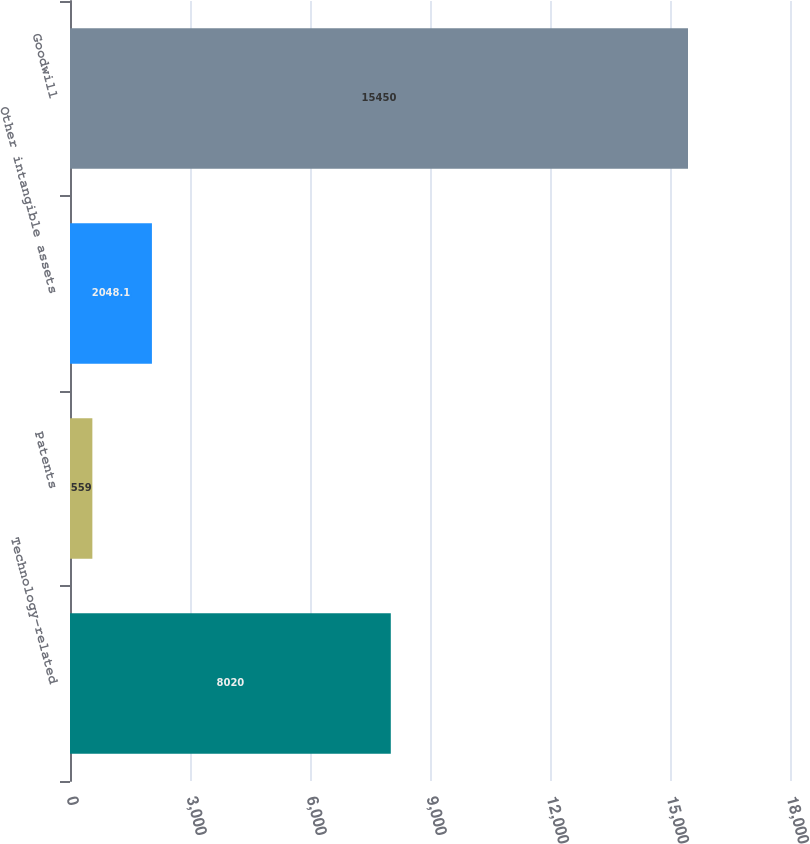<chart> <loc_0><loc_0><loc_500><loc_500><bar_chart><fcel>Technology-related<fcel>Patents<fcel>Other intangible assets<fcel>Goodwill<nl><fcel>8020<fcel>559<fcel>2048.1<fcel>15450<nl></chart> 